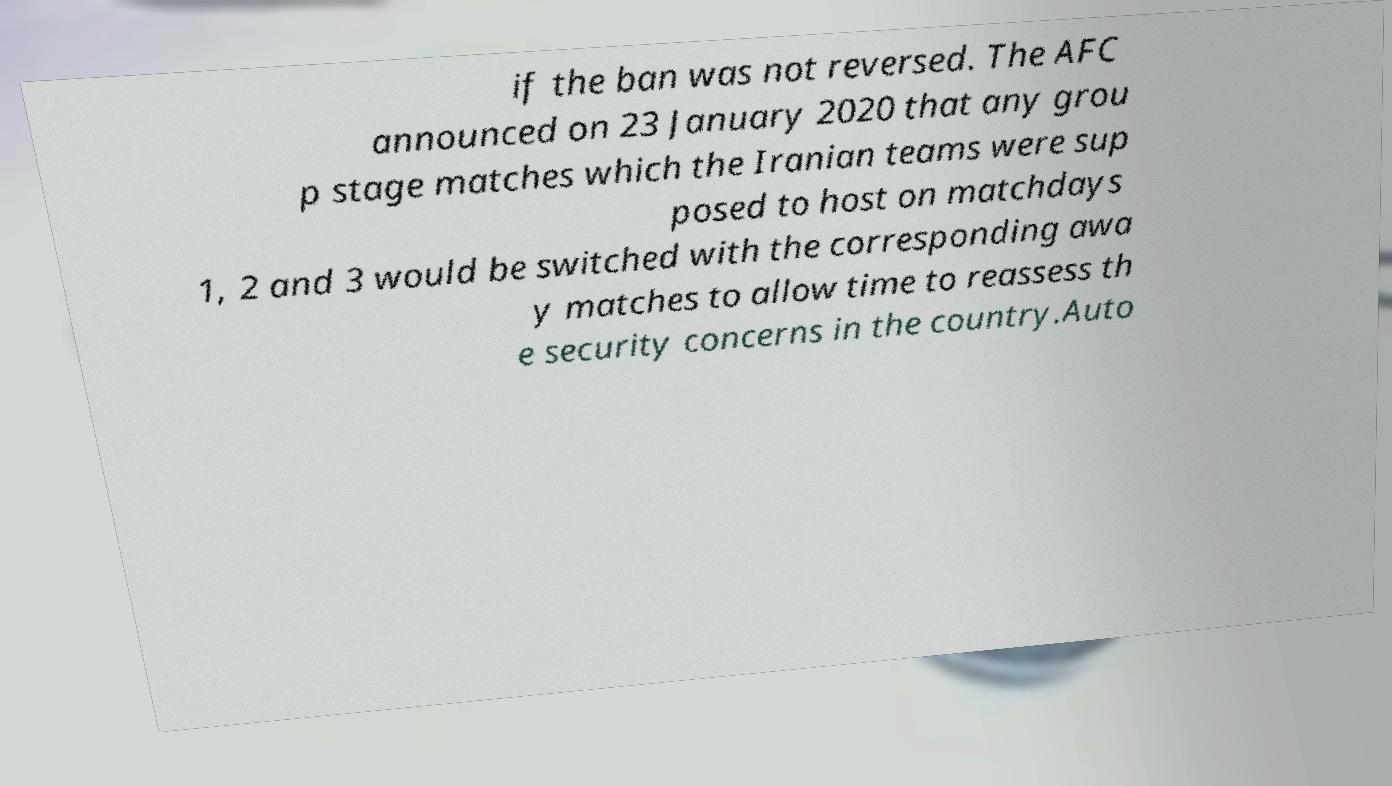For documentation purposes, I need the text within this image transcribed. Could you provide that? if the ban was not reversed. The AFC announced on 23 January 2020 that any grou p stage matches which the Iranian teams were sup posed to host on matchdays 1, 2 and 3 would be switched with the corresponding awa y matches to allow time to reassess th e security concerns in the country.Auto 